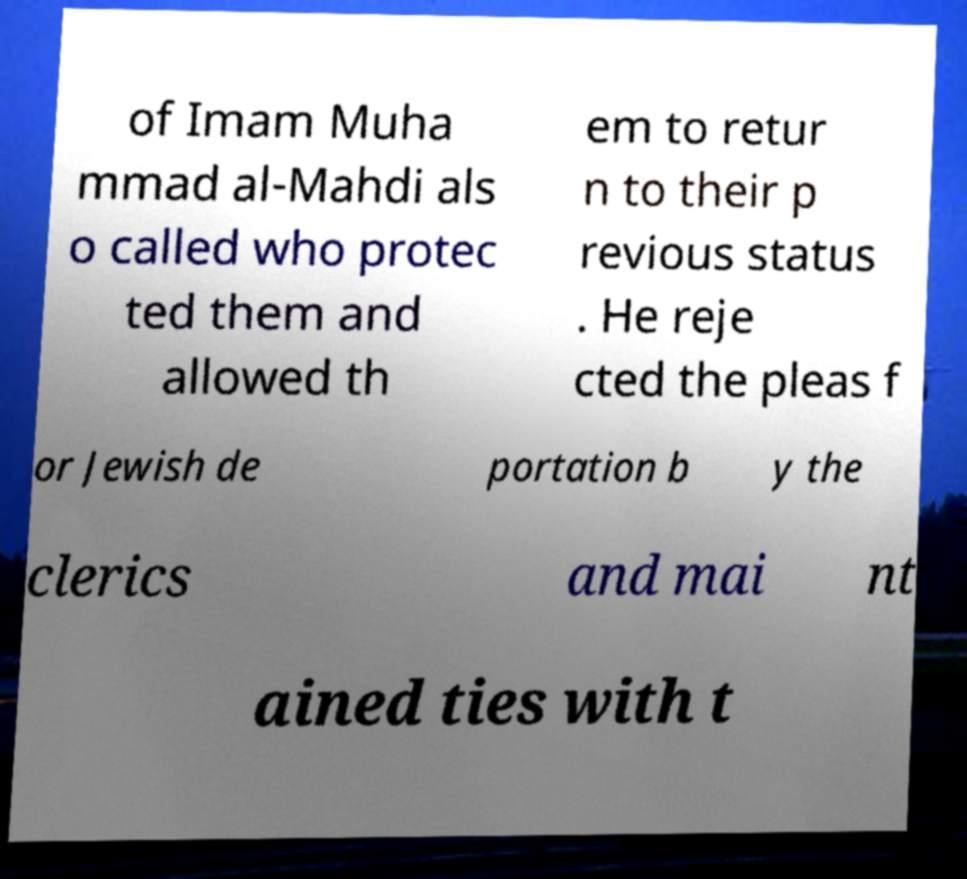What messages or text are displayed in this image? I need them in a readable, typed format. of Imam Muha mmad al-Mahdi als o called who protec ted them and allowed th em to retur n to their p revious status . He reje cted the pleas f or Jewish de portation b y the clerics and mai nt ained ties with t 